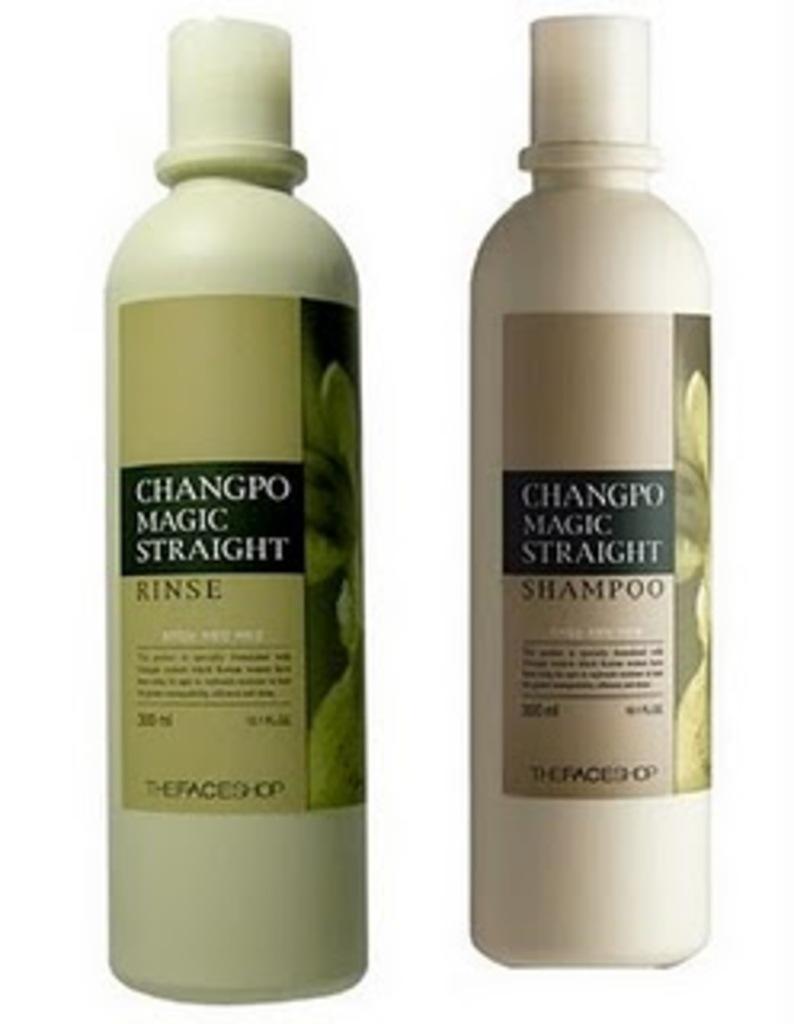What are these treatments supposed to do with curly hair?
Offer a very short reply. Straighten. What company made these products?
Ensure brevity in your answer.  Thefaceshop. 